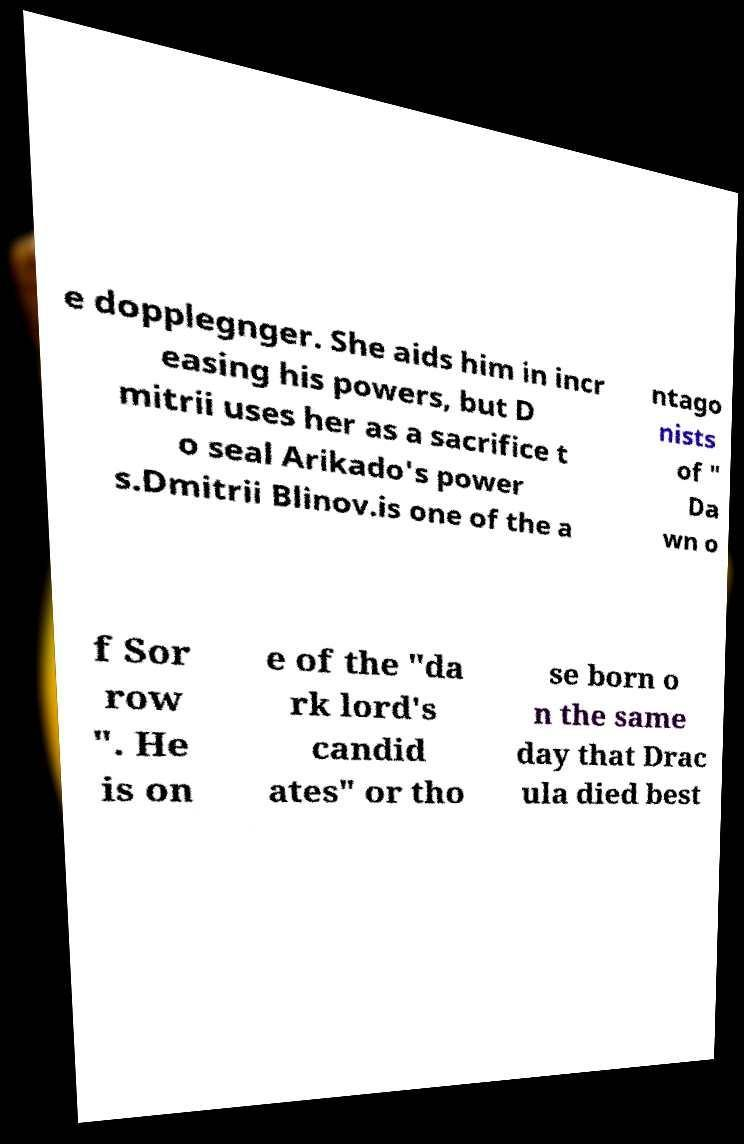Can you accurately transcribe the text from the provided image for me? e dopplegnger. She aids him in incr easing his powers, but D mitrii uses her as a sacrifice t o seal Arikado's power s.Dmitrii Blinov.is one of the a ntago nists of " Da wn o f Sor row ". He is on e of the "da rk lord's candid ates" or tho se born o n the same day that Drac ula died best 